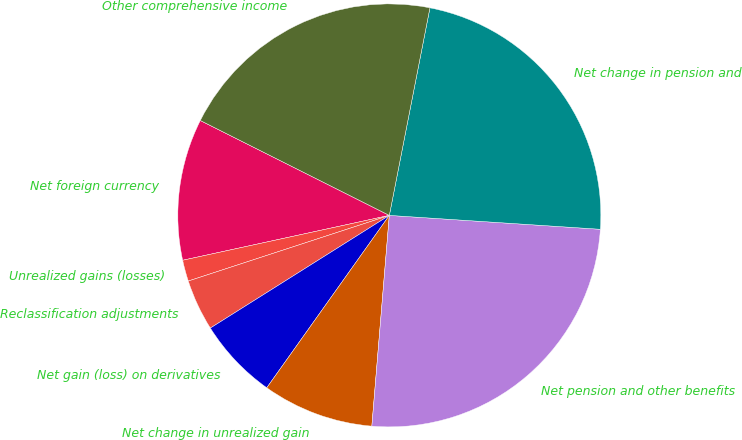Convert chart to OTSL. <chart><loc_0><loc_0><loc_500><loc_500><pie_chart><fcel>Net foreign currency<fcel>Unrealized gains (losses)<fcel>Reclassification adjustments<fcel>Net gain (loss) on derivatives<fcel>Net change in unrealized gain<fcel>Net pension and other benefits<fcel>Net change in pension and<fcel>Other comprehensive income<nl><fcel>10.81%<fcel>1.62%<fcel>3.92%<fcel>6.22%<fcel>8.52%<fcel>25.27%<fcel>22.97%<fcel>20.67%<nl></chart> 